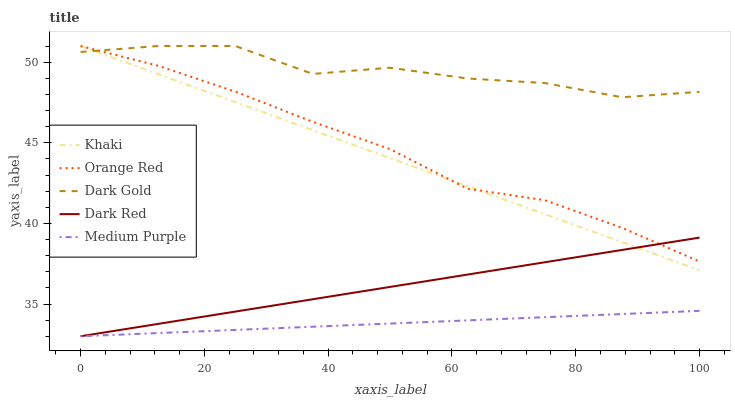Does Dark Red have the minimum area under the curve?
Answer yes or no. No. Does Dark Red have the maximum area under the curve?
Answer yes or no. No. Is Dark Red the smoothest?
Answer yes or no. No. Is Dark Red the roughest?
Answer yes or no. No. Does Khaki have the lowest value?
Answer yes or no. No. Does Dark Red have the highest value?
Answer yes or no. No. Is Medium Purple less than Orange Red?
Answer yes or no. Yes. Is Orange Red greater than Medium Purple?
Answer yes or no. Yes. Does Medium Purple intersect Orange Red?
Answer yes or no. No. 